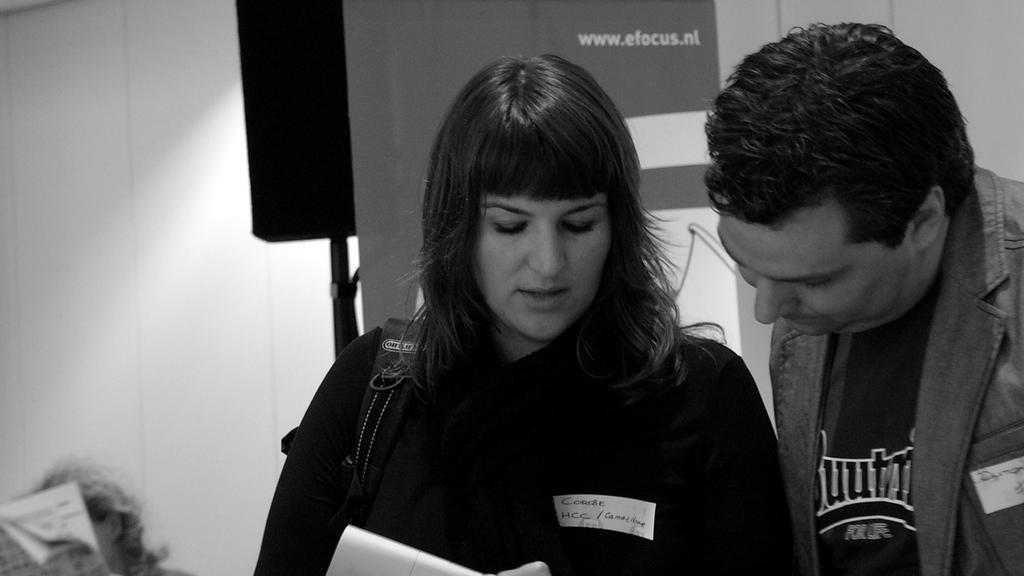Provide a one-sentence caption for the provided image. A man and a woman discussing something with website, www.efocus.nl shown behind them. 